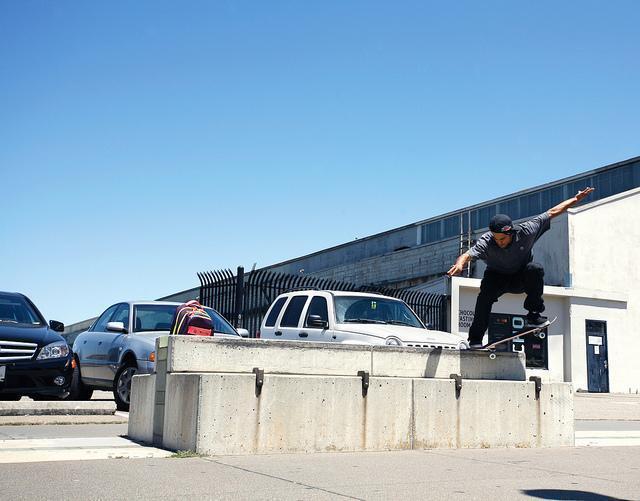What is the man on the board doing on the ledge?
Choose the right answer from the provided options to respond to the question.
Options: Flipping, grinding, waxing, manualing. Grinding. 